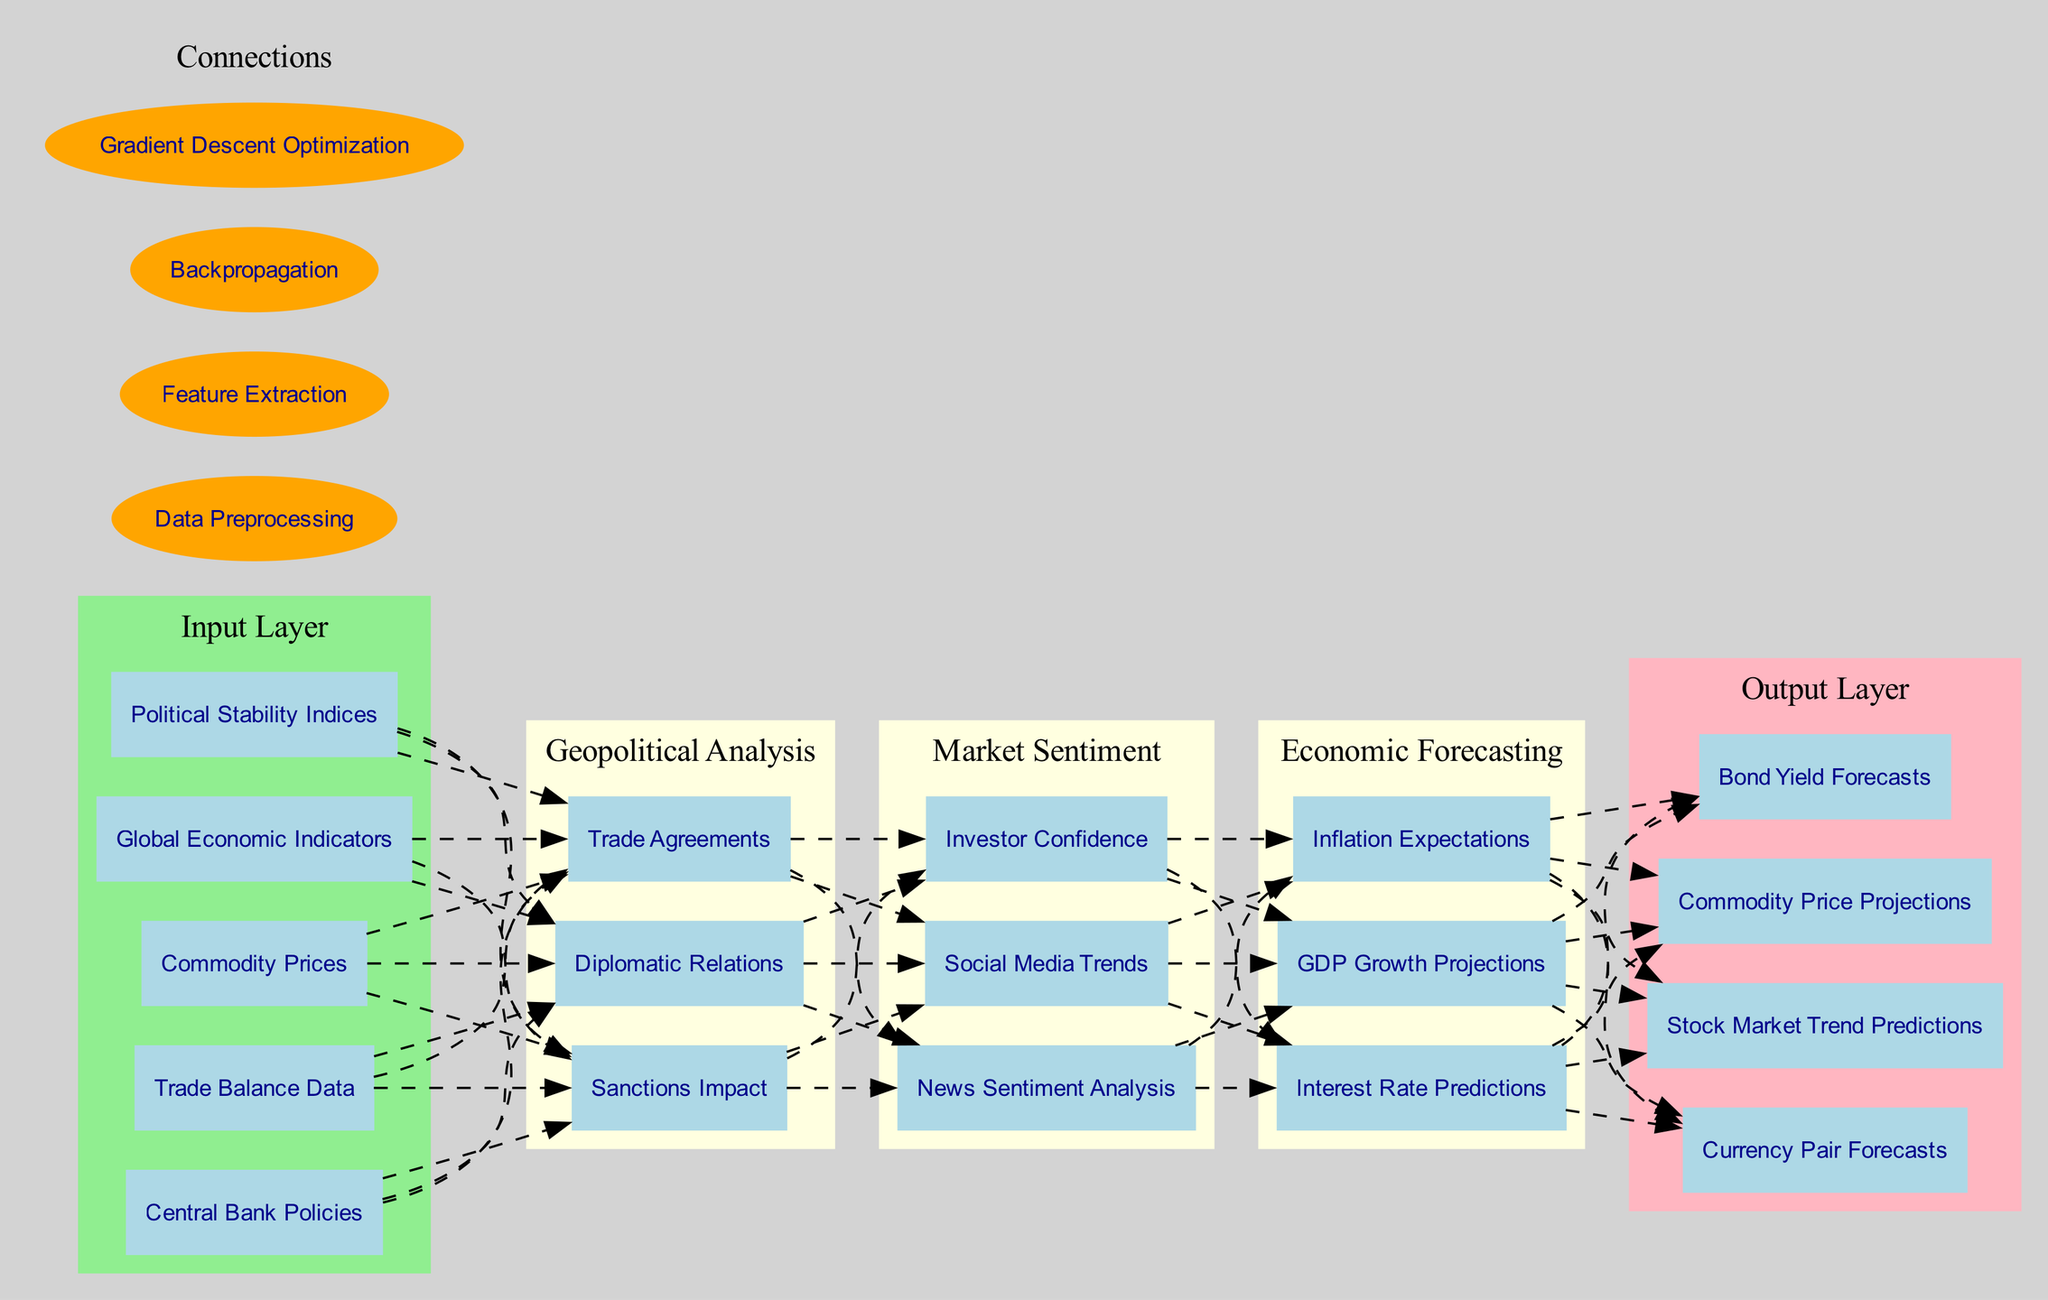What are the nodes in the input layer? The input layer has five nodes which include Global Economic Indicators, Political Stability Indices, Central Bank Policies, Trade Balance Data, and Commodity Prices. These are explicitly listed in the diagram under the input layer section.
Answer: Global Economic Indicators, Political Stability Indices, Central Bank Policies, Trade Balance Data, Commodity Prices How many nodes are in the "Market Sentiment" hidden layer? The "Market Sentiment" hidden layer contains three nodes: Social Media Trends, Investor Confidence, and News Sentiment Analysis, as indicated by the diagram structure showing the nodes under this specific layer.
Answer: 3 Which element connects the input layer to the "Geopolitical Analysis" hidden layer? The connection between the input layer and the "Geopolitical Analysis" hidden layer is established by data preprocessing, which is part of the connections listed in the legend of the diagram.
Answer: Data Preprocessing What is the output layer forecast that corresponds to currency predictions? The output layer includes Currency Pair Forecasts, which directly correspond to the predictions being made regarding currency fluctuations, as labeled in the output section of the diagram.
Answer: Currency Pair Forecasts Which hidden layer includes "GDP Growth Projections" as a node? The "Economic Forecasting" hidden layer includes "GDP Growth Projections" among its nodes, as stated in the hidden layer's details shown in the diagram.
Answer: Economic Forecasting How many hidden layers are present in the diagram? There are three hidden layers present in the diagram: "Geopolitical Analysis," "Market Sentiment," and "Economic Forecasting," as indicated in the structure of the neural network.
Answer: 3 What is the last node in the output layer? The last node in the output layer is Bond Yield Forecasts, as it is the final entry listed among the output nodes in the diagram.
Answer: Bond Yield Forecasts Which method is used for optimization in the diagram? The method used for optimization as indicated in the connections section of the diagram is Gradient Descent Optimization, which is a common technique for adjusting weights in neural networks.
Answer: Gradient Descent Optimization What type of analysis is represented in the "Geopolitical Analysis" hidden layer? The type of analysis in the "Geopolitical Analysis" hidden layer focuses on Diplomatic Relations, Trade Agreements, and Sanctions Impact, which collectively impact geopolitical factors influencing market trends.
Answer: Geopolitical factors 